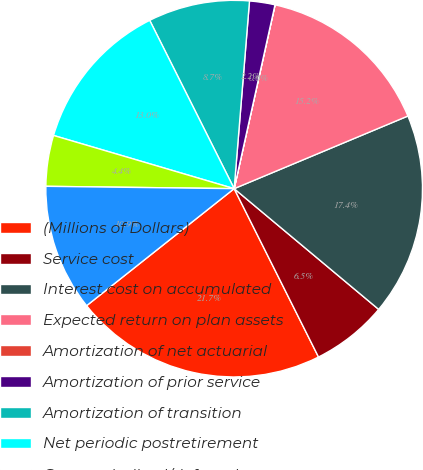Convert chart to OTSL. <chart><loc_0><loc_0><loc_500><loc_500><pie_chart><fcel>(Millions of Dollars)<fcel>Service cost<fcel>Interest cost on accumulated<fcel>Expected return on plan assets<fcel>Amortization of net actuarial<fcel>Amortization of prior service<fcel>Amortization of transition<fcel>Net periodic postretirement<fcel>Cost capitalized/deferred<fcel>Cost charged to operating<nl><fcel>21.72%<fcel>6.53%<fcel>17.38%<fcel>15.21%<fcel>0.01%<fcel>2.18%<fcel>8.7%<fcel>13.04%<fcel>4.36%<fcel>10.87%<nl></chart> 